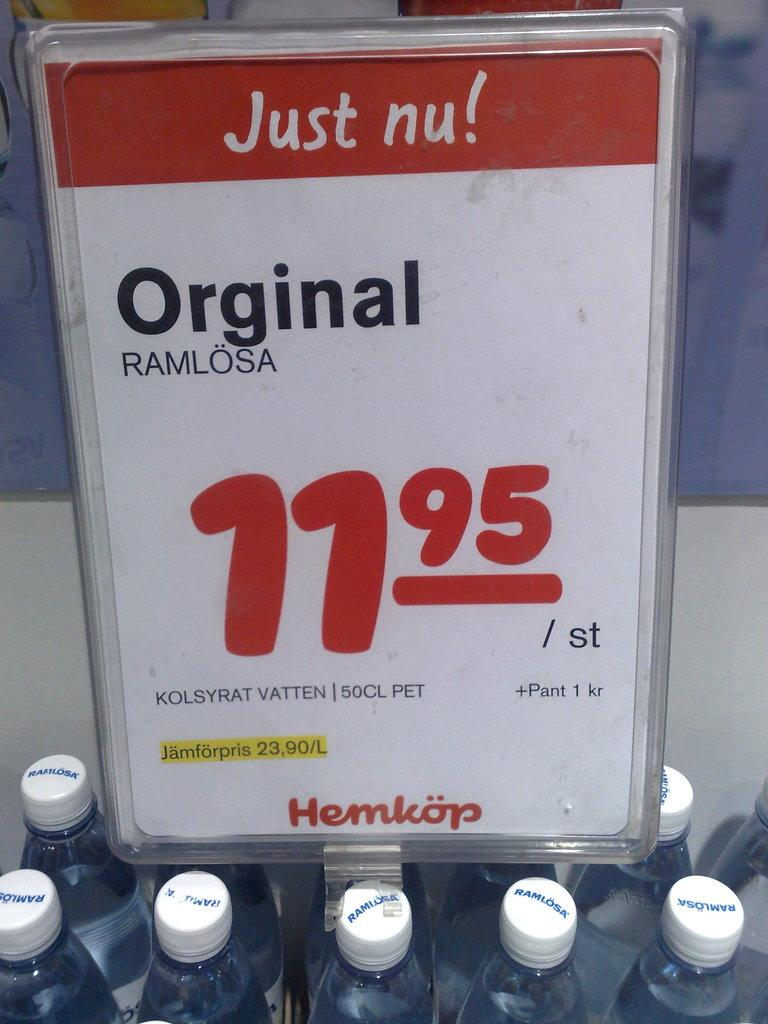What objects are grouped together in the image? There is a group of bottles in the image. What information is provided about the bottles in the image? There is a price card present above the bottles. What song is being sung by the hat in the image? There is no hat or song present in the image. 